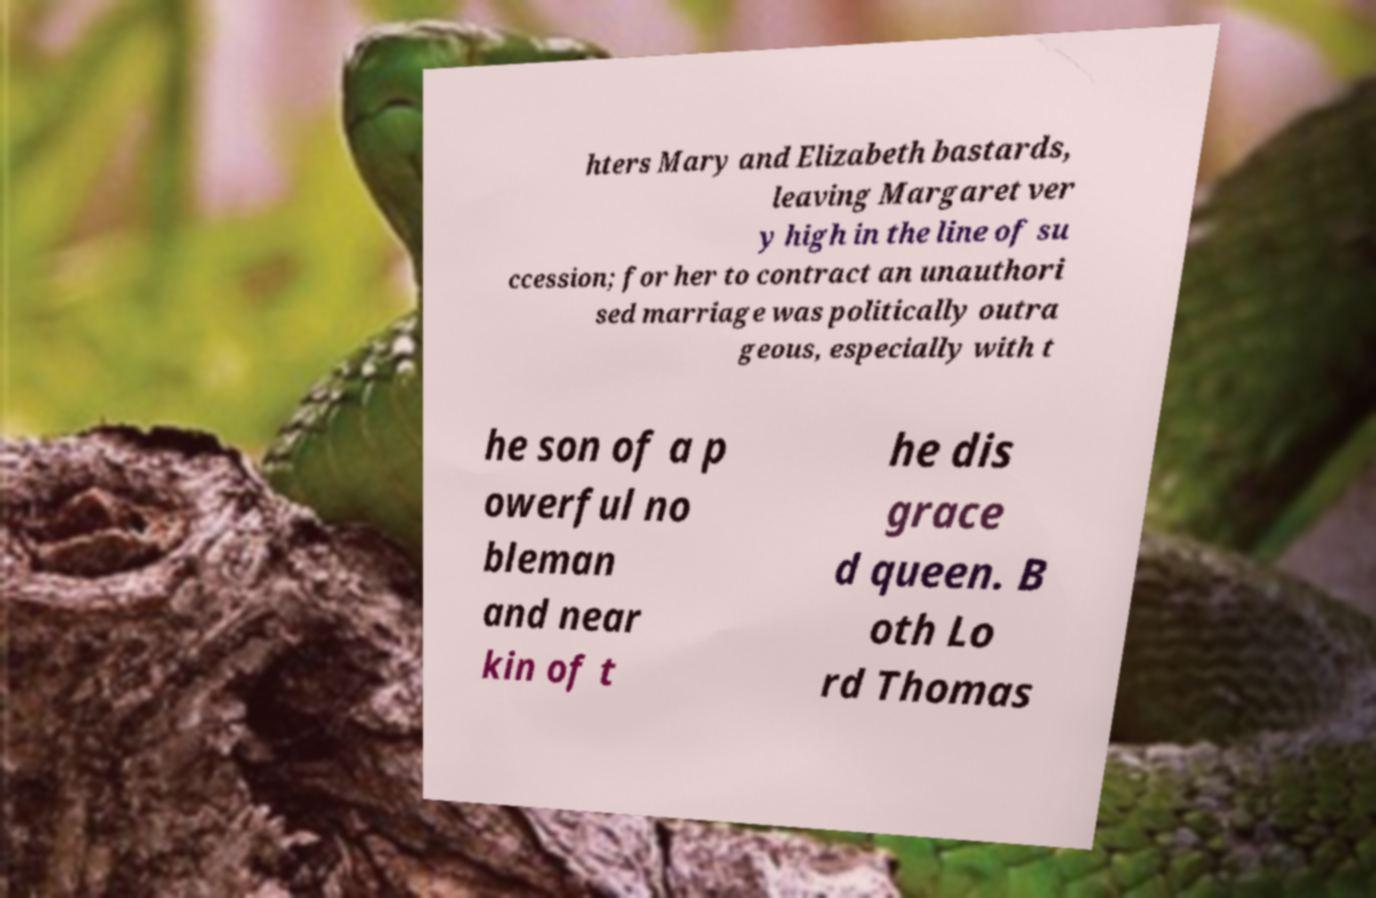Can you accurately transcribe the text from the provided image for me? hters Mary and Elizabeth bastards, leaving Margaret ver y high in the line of su ccession; for her to contract an unauthori sed marriage was politically outra geous, especially with t he son of a p owerful no bleman and near kin of t he dis grace d queen. B oth Lo rd Thomas 